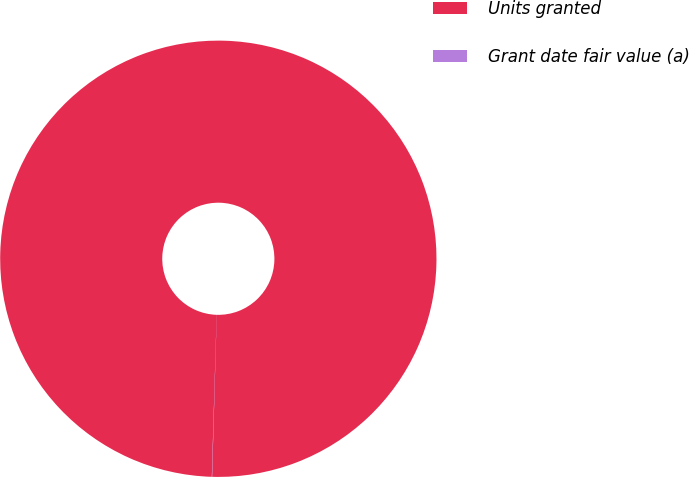Convert chart to OTSL. <chart><loc_0><loc_0><loc_500><loc_500><pie_chart><fcel>Units granted<fcel>Grant date fair value (a)<nl><fcel>99.98%<fcel>0.02%<nl></chart> 